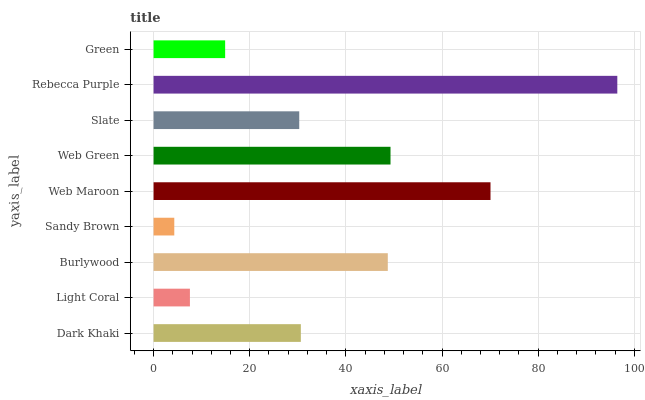Is Sandy Brown the minimum?
Answer yes or no. Yes. Is Rebecca Purple the maximum?
Answer yes or no. Yes. Is Light Coral the minimum?
Answer yes or no. No. Is Light Coral the maximum?
Answer yes or no. No. Is Dark Khaki greater than Light Coral?
Answer yes or no. Yes. Is Light Coral less than Dark Khaki?
Answer yes or no. Yes. Is Light Coral greater than Dark Khaki?
Answer yes or no. No. Is Dark Khaki less than Light Coral?
Answer yes or no. No. Is Dark Khaki the high median?
Answer yes or no. Yes. Is Dark Khaki the low median?
Answer yes or no. Yes. Is Burlywood the high median?
Answer yes or no. No. Is Slate the low median?
Answer yes or no. No. 